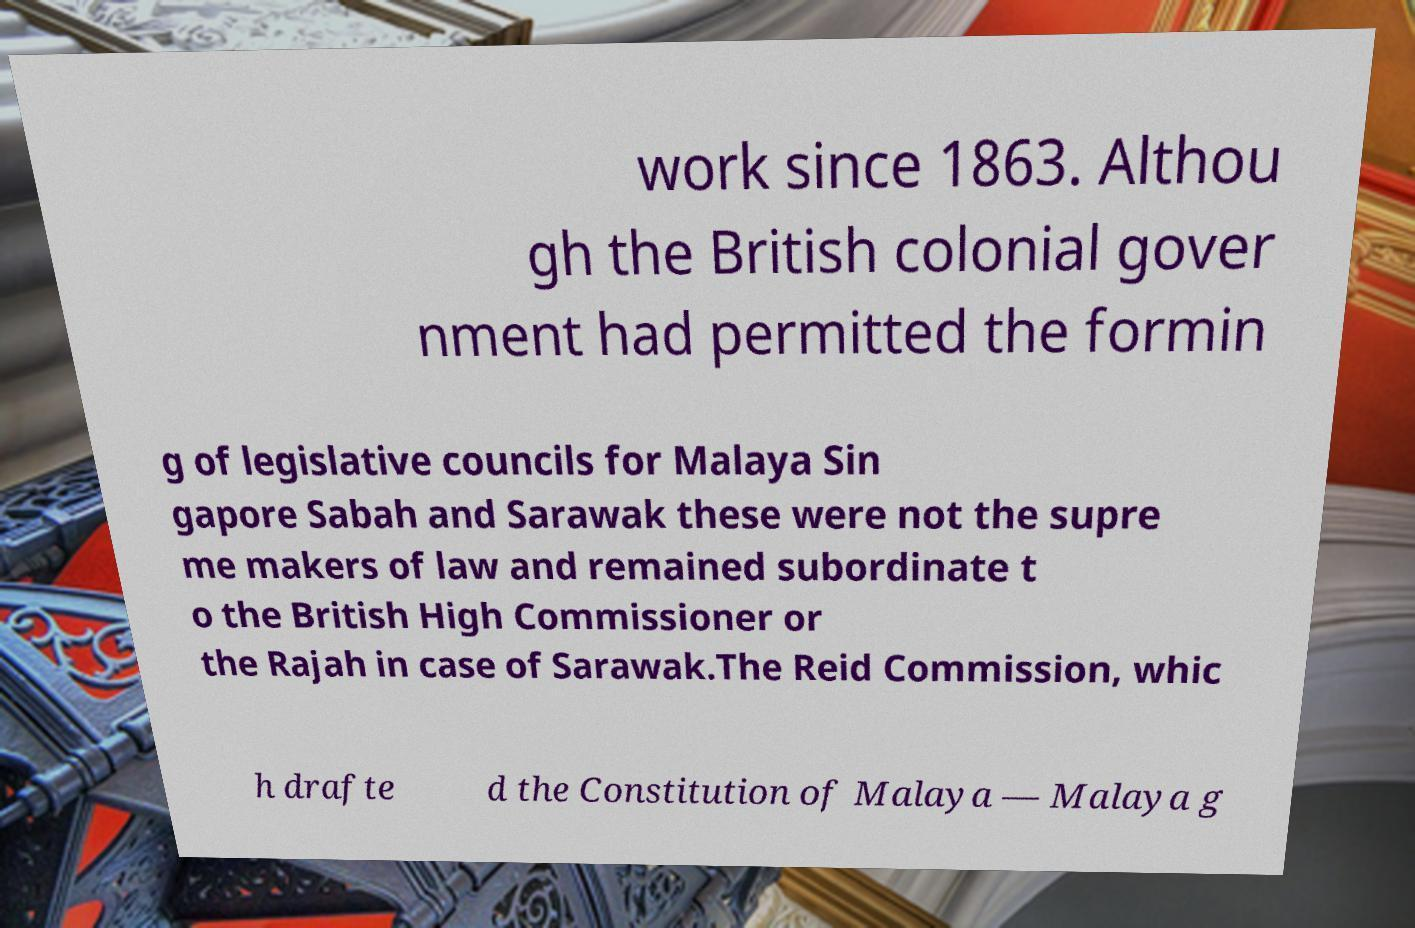I need the written content from this picture converted into text. Can you do that? work since 1863. Althou gh the British colonial gover nment had permitted the formin g of legislative councils for Malaya Sin gapore Sabah and Sarawak these were not the supre me makers of law and remained subordinate t o the British High Commissioner or the Rajah in case of Sarawak.The Reid Commission, whic h drafte d the Constitution of Malaya — Malaya g 